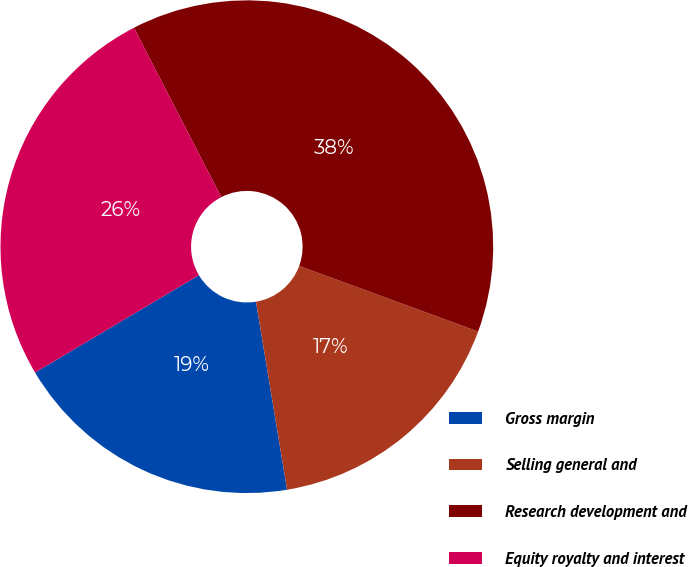<chart> <loc_0><loc_0><loc_500><loc_500><pie_chart><fcel>Gross margin<fcel>Selling general and<fcel>Research development and<fcel>Equity royalty and interest<nl><fcel>19.08%<fcel>16.79%<fcel>38.17%<fcel>25.95%<nl></chart> 